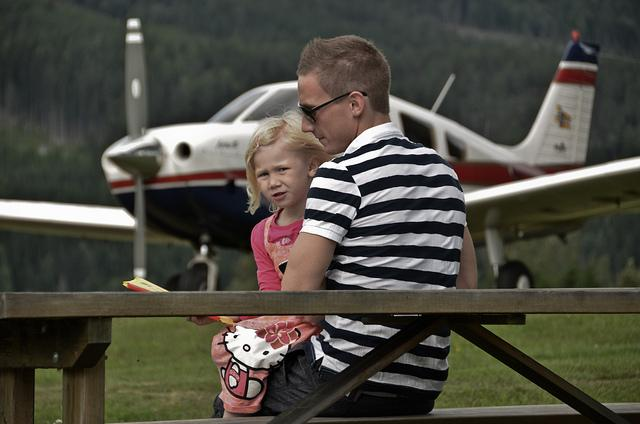What is the thing on the front tip of the airplane? Please explain your reasoning. propeller. Long thin boards protrude from a circular object on the front of a plane. 